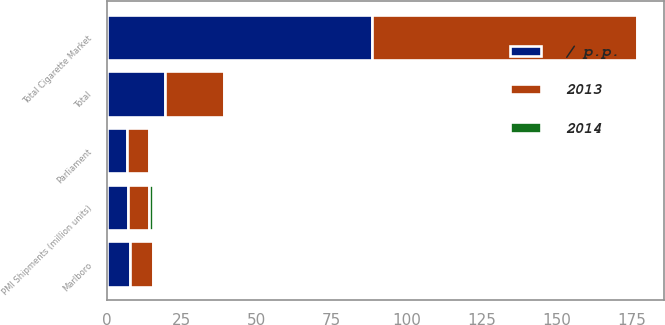Convert chart to OTSL. <chart><loc_0><loc_0><loc_500><loc_500><stacked_bar_chart><ecel><fcel>Total Cigarette Market<fcel>PMI Shipments (million units)<fcel>Marlboro<fcel>Parliament<fcel>Total<nl><fcel>2013<fcel>88.1<fcel>7.1<fcel>7.8<fcel>7.1<fcel>19.7<nl><fcel>/ p.p.<fcel>88.4<fcel>7.1<fcel>7.7<fcel>6.9<fcel>19.4<nl><fcel>2014<fcel>0.4<fcel>1.1<fcel>0.1<fcel>0.2<fcel>0.3<nl></chart> 